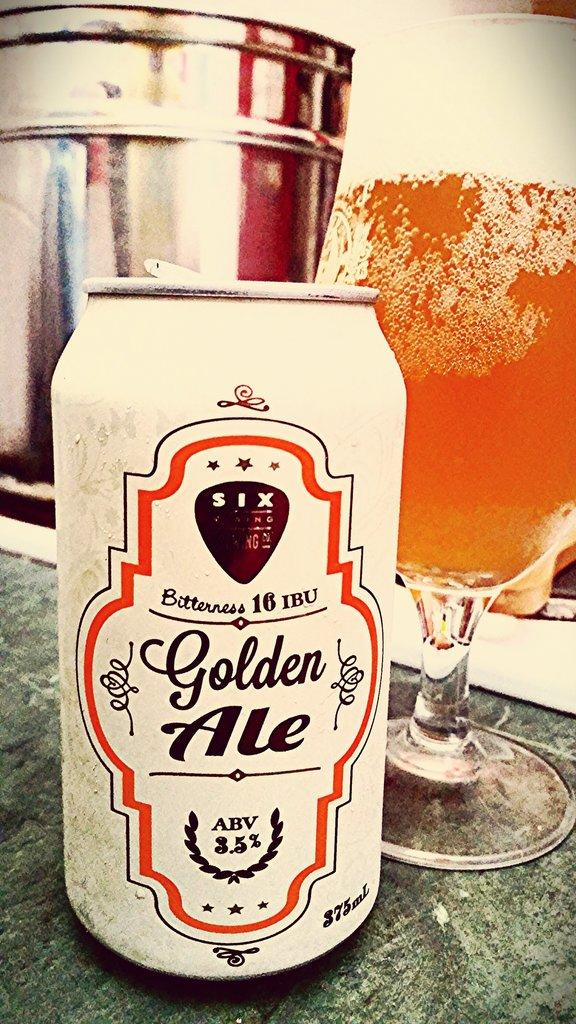<image>
Give a short and clear explanation of the subsequent image. A white can of Golden Ale sits next to a frosted glass filled with the liquid. 